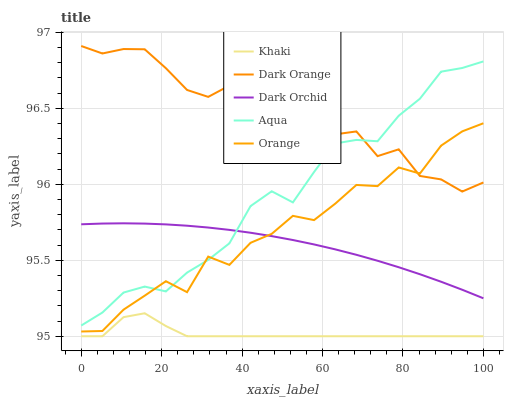Does Khaki have the minimum area under the curve?
Answer yes or no. Yes. Does Dark Orange have the maximum area under the curve?
Answer yes or no. Yes. Does Dark Orange have the minimum area under the curve?
Answer yes or no. No. Does Khaki have the maximum area under the curve?
Answer yes or no. No. Is Dark Orchid the smoothest?
Answer yes or no. Yes. Is Orange the roughest?
Answer yes or no. Yes. Is Dark Orange the smoothest?
Answer yes or no. No. Is Dark Orange the roughest?
Answer yes or no. No. Does Dark Orange have the lowest value?
Answer yes or no. No. Does Dark Orange have the highest value?
Answer yes or no. Yes. Does Khaki have the highest value?
Answer yes or no. No. Is Khaki less than Dark Orange?
Answer yes or no. Yes. Is Aqua greater than Khaki?
Answer yes or no. Yes. Does Dark Orange intersect Orange?
Answer yes or no. Yes. Is Dark Orange less than Orange?
Answer yes or no. No. Is Dark Orange greater than Orange?
Answer yes or no. No. Does Khaki intersect Dark Orange?
Answer yes or no. No. 